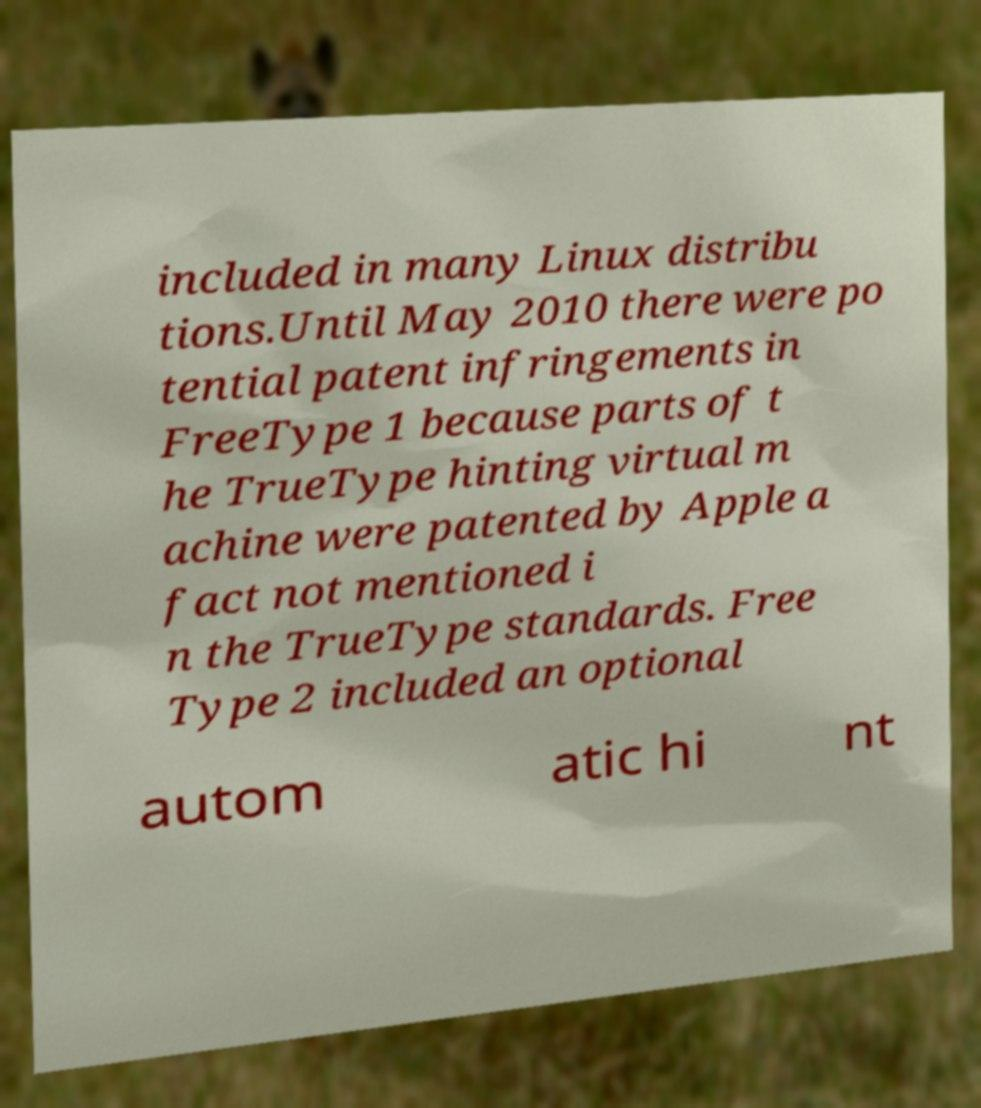Can you accurately transcribe the text from the provided image for me? included in many Linux distribu tions.Until May 2010 there were po tential patent infringements in FreeType 1 because parts of t he TrueType hinting virtual m achine were patented by Apple a fact not mentioned i n the TrueType standards. Free Type 2 included an optional autom atic hi nt 